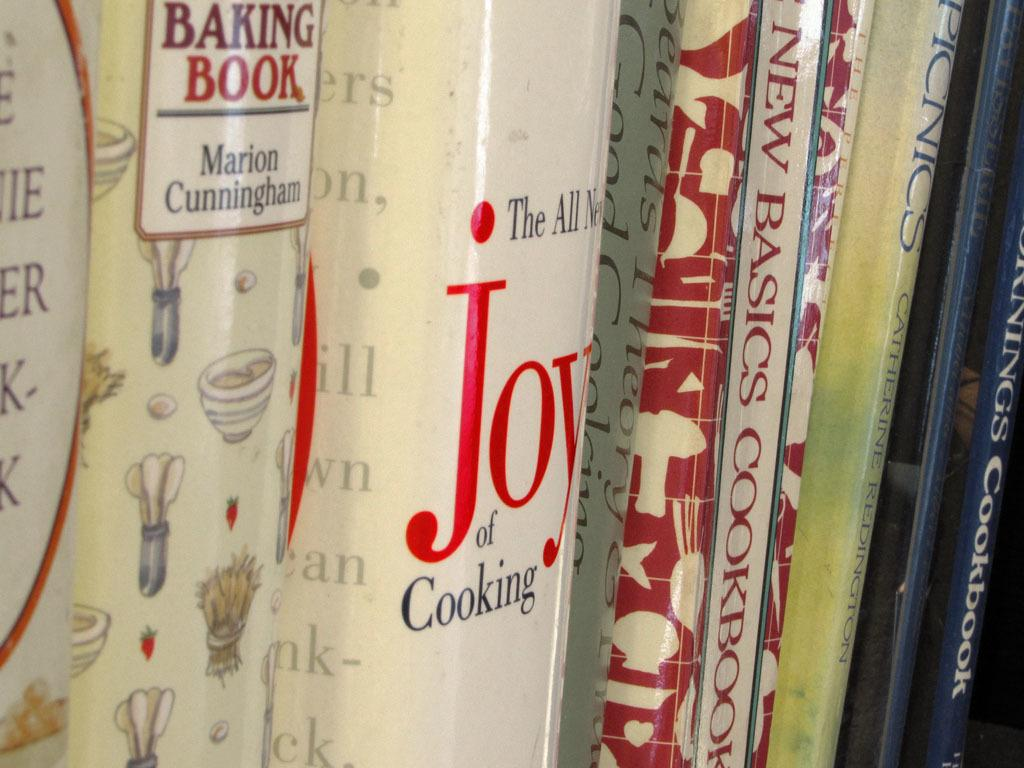<image>
Summarize the visual content of the image. Books lined up one in the middle called Joy 